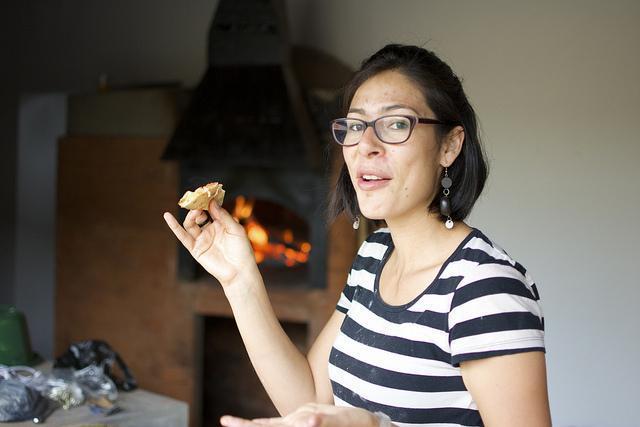How many people are in the shot?
Give a very brief answer. 1. 